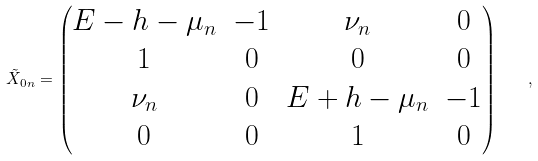<formula> <loc_0><loc_0><loc_500><loc_500>\tilde { X } _ { 0 n } = \begin{pmatrix} E - h - \mu _ { n } & - 1 & \nu _ { n } & 0 \\ 1 & 0 & 0 & 0 \\ \nu _ { n } & 0 & E + h - \mu _ { n } & - 1 \\ 0 & 0 & 1 & 0 \end{pmatrix} \quad ,</formula> 